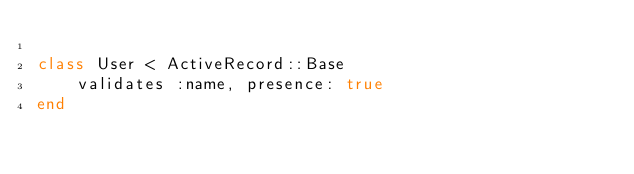Convert code to text. <code><loc_0><loc_0><loc_500><loc_500><_Ruby_>
class User < ActiveRecord::Base
    validates :name, presence: true
end </code> 